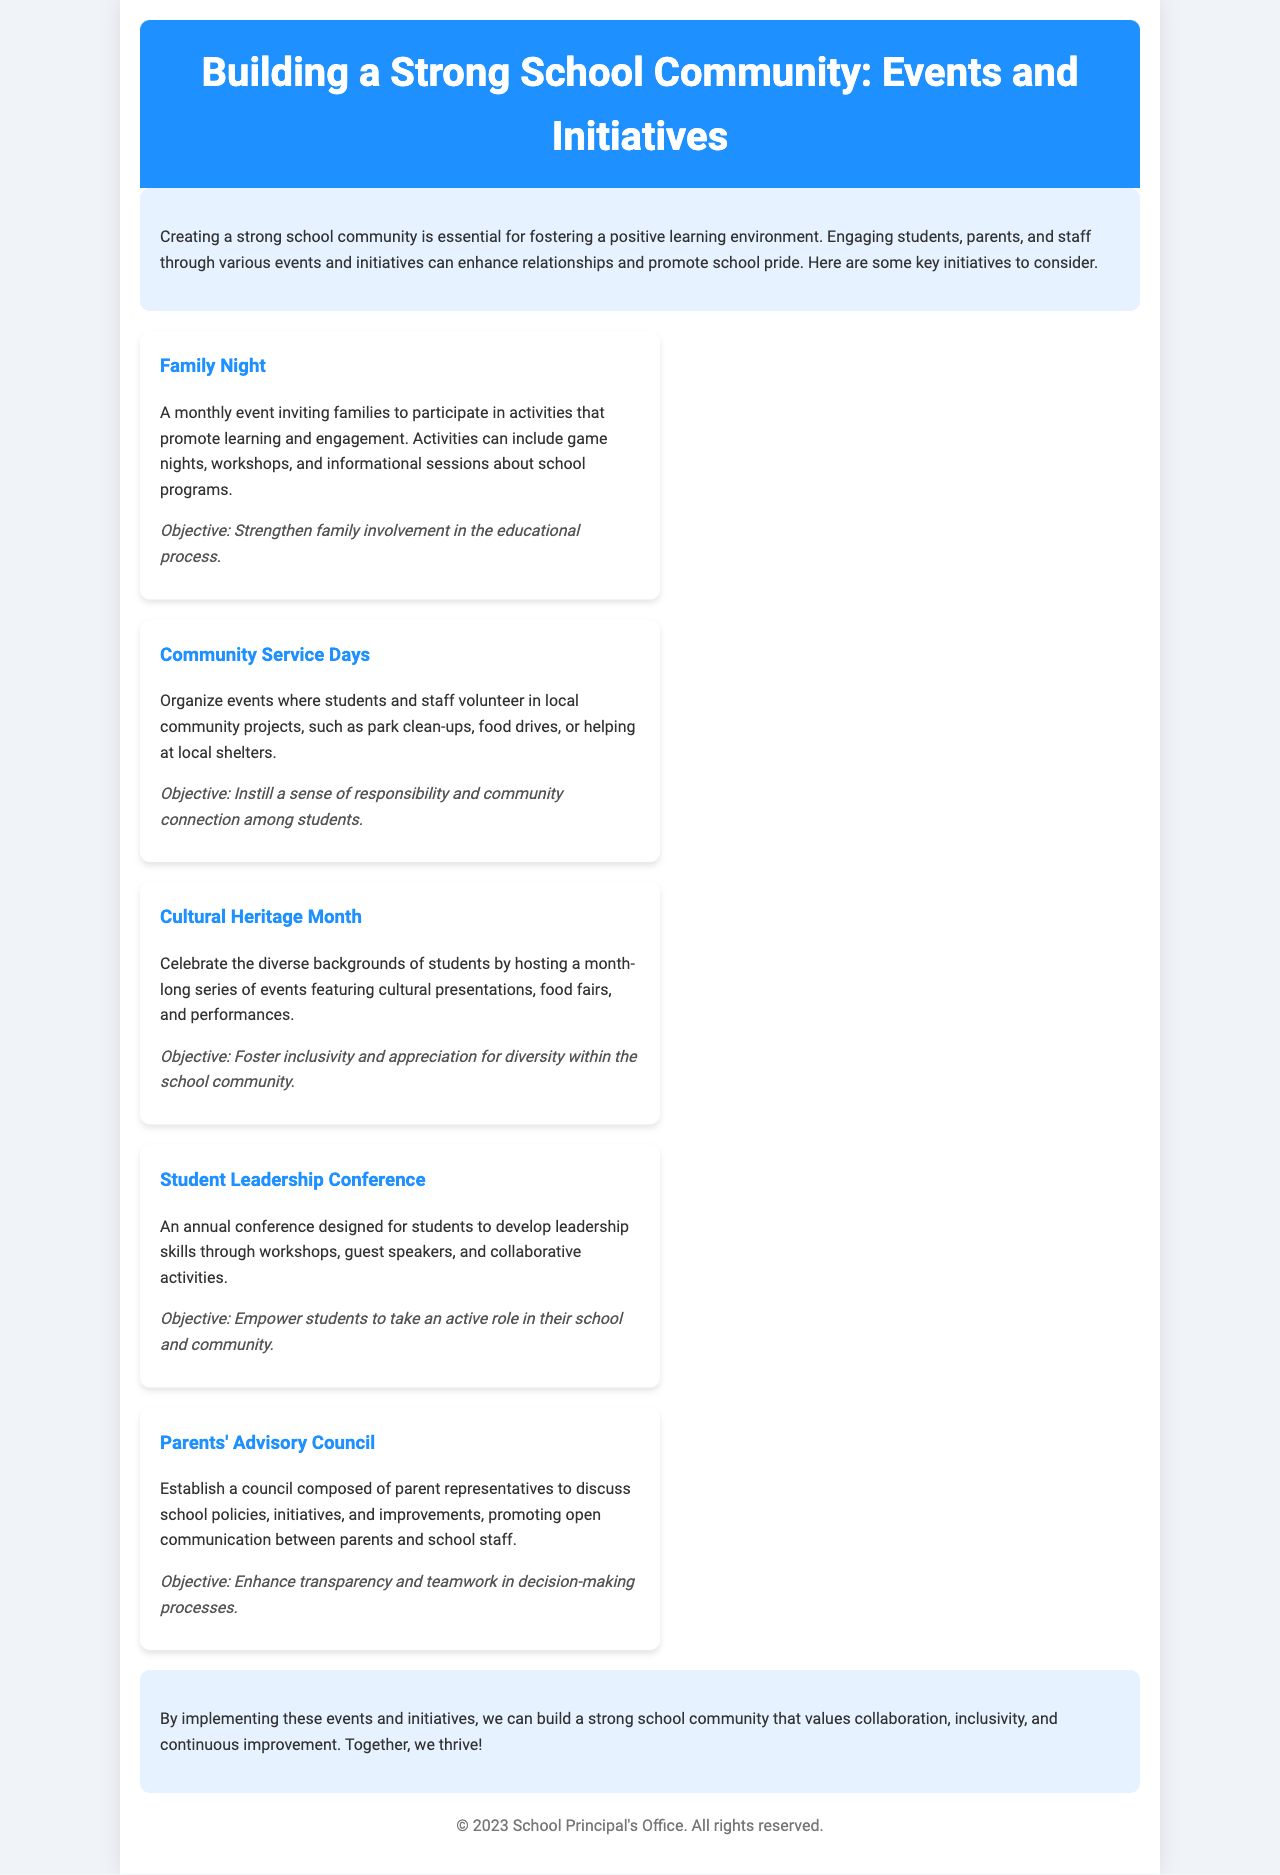What is the title of the brochure? The title of the brochure is located in the header section, prominently displayed as the main heading.
Answer: Building a Strong School Community: Events and Initiatives What event encourages family involvement? The document specifies an event designed to enhance family participation in learning and school activities.
Answer: Family Night What is one of the objectives of Community Service Days? The document outlines the goals of this event that aims to instill certain values among students.
Answer: Instill a sense of responsibility and community connection How often does Family Night occur? The brochure specifies the frequency of this event aimed at engaging families.
Answer: Monthly What event aims to celebrate diversity? The document highlights an initiative dedicated to recognizing various cultural backgrounds within the school community.
Answer: Cultural Heritage Month What initiative helps parents communicate with school staff? The brochure includes a mention of a group that facilitates discussions between parents and the school.
Answer: Parents' Advisory Council How many events are listed in the document? The total number of specific events mentioned in the brochure illustrates various initiatives available to the community.
Answer: Five What is the objective of the Student Leadership Conference? The document explains the purpose of this annual gathering aimed at developing certain skills in students.
Answer: Empower students to take an active role in their school and community 